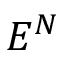<formula> <loc_0><loc_0><loc_500><loc_500>E ^ { N }</formula> 